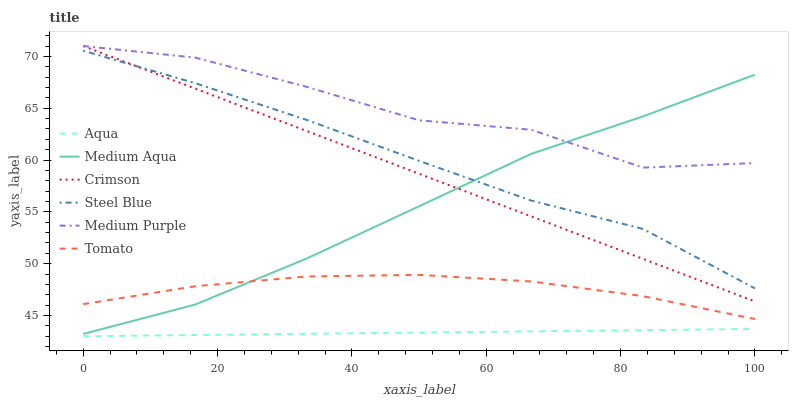Does Aqua have the minimum area under the curve?
Answer yes or no. Yes. Does Medium Purple have the maximum area under the curve?
Answer yes or no. Yes. Does Steel Blue have the minimum area under the curve?
Answer yes or no. No. Does Steel Blue have the maximum area under the curve?
Answer yes or no. No. Is Aqua the smoothest?
Answer yes or no. Yes. Is Medium Purple the roughest?
Answer yes or no. Yes. Is Steel Blue the smoothest?
Answer yes or no. No. Is Steel Blue the roughest?
Answer yes or no. No. Does Aqua have the lowest value?
Answer yes or no. Yes. Does Steel Blue have the lowest value?
Answer yes or no. No. Does Crimson have the highest value?
Answer yes or no. Yes. Does Steel Blue have the highest value?
Answer yes or no. No. Is Aqua less than Crimson?
Answer yes or no. Yes. Is Crimson greater than Tomato?
Answer yes or no. Yes. Does Medium Aqua intersect Steel Blue?
Answer yes or no. Yes. Is Medium Aqua less than Steel Blue?
Answer yes or no. No. Is Medium Aqua greater than Steel Blue?
Answer yes or no. No. Does Aqua intersect Crimson?
Answer yes or no. No. 